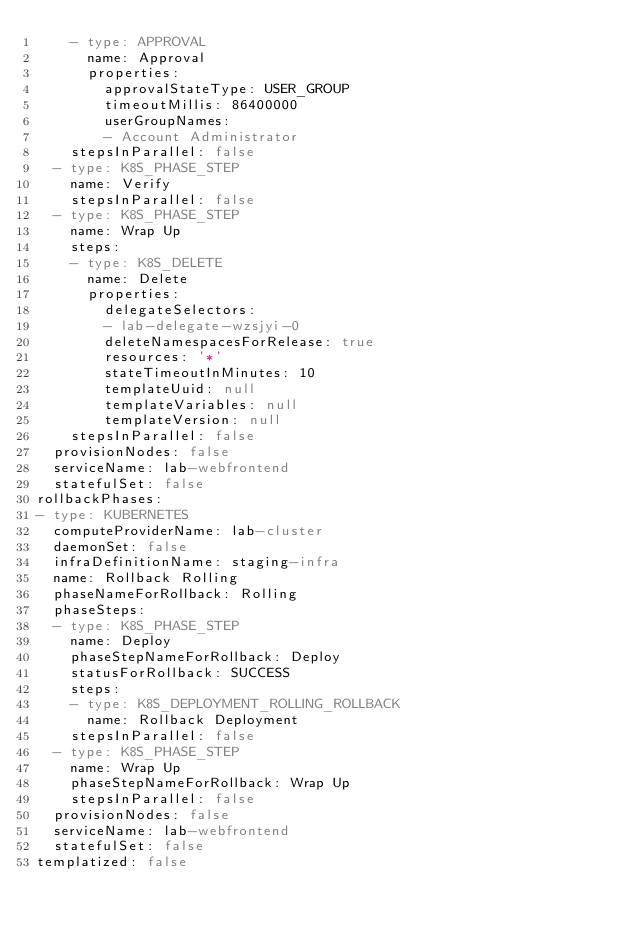<code> <loc_0><loc_0><loc_500><loc_500><_YAML_>    - type: APPROVAL
      name: Approval
      properties:
        approvalStateType: USER_GROUP
        timeoutMillis: 86400000
        userGroupNames:
        - Account Administrator
    stepsInParallel: false
  - type: K8S_PHASE_STEP
    name: Verify
    stepsInParallel: false
  - type: K8S_PHASE_STEP
    name: Wrap Up
    steps:
    - type: K8S_DELETE
      name: Delete
      properties:
        delegateSelectors:
        - lab-delegate-wzsjyi-0
        deleteNamespacesForRelease: true
        resources: '*'
        stateTimeoutInMinutes: 10
        templateUuid: null
        templateVariables: null
        templateVersion: null
    stepsInParallel: false
  provisionNodes: false
  serviceName: lab-webfrontend
  statefulSet: false
rollbackPhases:
- type: KUBERNETES
  computeProviderName: lab-cluster
  daemonSet: false
  infraDefinitionName: staging-infra
  name: Rollback Rolling
  phaseNameForRollback: Rolling
  phaseSteps:
  - type: K8S_PHASE_STEP
    name: Deploy
    phaseStepNameForRollback: Deploy
    statusForRollback: SUCCESS
    steps:
    - type: K8S_DEPLOYMENT_ROLLING_ROLLBACK
      name: Rollback Deployment
    stepsInParallel: false
  - type: K8S_PHASE_STEP
    name: Wrap Up
    phaseStepNameForRollback: Wrap Up
    stepsInParallel: false
  provisionNodes: false
  serviceName: lab-webfrontend
  statefulSet: false
templatized: false
</code> 